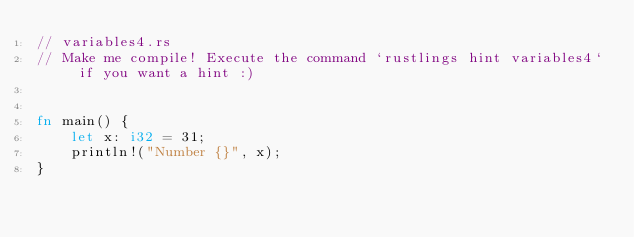<code> <loc_0><loc_0><loc_500><loc_500><_Rust_>// variables4.rs
// Make me compile! Execute the command `rustlings hint variables4` if you want a hint :)


fn main() {
    let x: i32 = 31;
    println!("Number {}", x);
}
</code> 